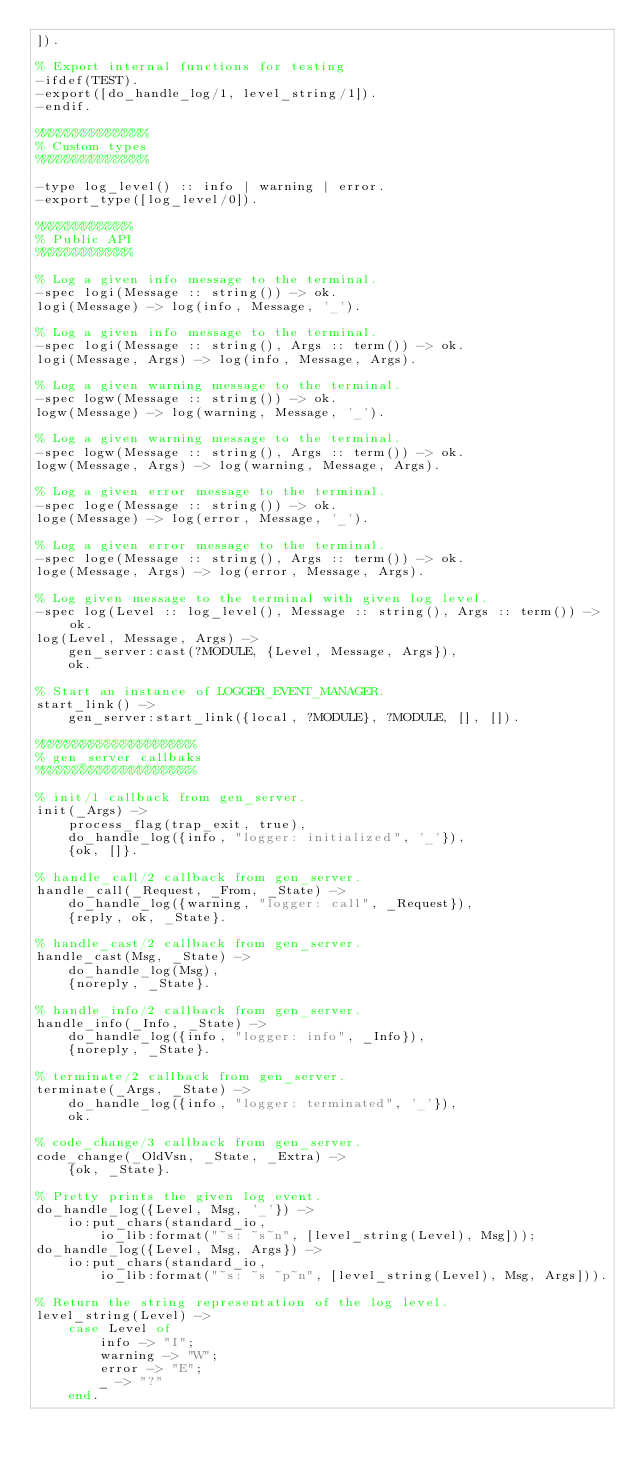Convert code to text. <code><loc_0><loc_0><loc_500><loc_500><_Erlang_>]).

% Export internal functions for testing
-ifdef(TEST).
-export([do_handle_log/1, level_string/1]).
-endif.

%%%%%%%%%%%%%%
% Custom types
%%%%%%%%%%%%%%

-type log_level() :: info | warning | error.
-export_type([log_level/0]).

%%%%%%%%%%%%
% Public API
%%%%%%%%%%%%

% Log a given info message to the terminal.
-spec logi(Message :: string()) -> ok.
logi(Message) -> log(info, Message, '_').

% Log a given info message to the terminal.
-spec logi(Message :: string(), Args :: term()) -> ok.
logi(Message, Args) -> log(info, Message, Args).

% Log a given warning message to the terminal.
-spec logw(Message :: string()) -> ok.
logw(Message) -> log(warning, Message, '_').

% Log a given warning message to the terminal.
-spec logw(Message :: string(), Args :: term()) -> ok.
logw(Message, Args) -> log(warning, Message, Args).

% Log a given error message to the terminal.
-spec loge(Message :: string()) -> ok.
loge(Message) -> log(error, Message, '_').

% Log a given error message to the terminal.
-spec loge(Message :: string(), Args :: term()) -> ok.
loge(Message, Args) -> log(error, Message, Args).

% Log given message to the terminal with given log level.
-spec log(Level :: log_level(), Message :: string(), Args :: term()) -> ok.
log(Level, Message, Args) ->
    gen_server:cast(?MODULE, {Level, Message, Args}),
    ok.

% Start an instance of LOGGER_EVENT_MANAGER.
start_link() ->
    gen_server:start_link({local, ?MODULE}, ?MODULE, [], []).

%%%%%%%%%%%%%%%%%%%%
% gen_server callbaks
%%%%%%%%%%%%%%%%%%%%

% init/1 callback from gen_server.
init(_Args) -> 
    process_flag(trap_exit, true),
    do_handle_log({info, "logger: initialized", '_'}),
    {ok, []}.

% handle_call/2 callback from gen_server.
handle_call(_Request, _From, _State) -> 
    do_handle_log({warning, "logger: call", _Request}),
    {reply, ok, _State}.

% handle_cast/2 callback from gen_server.
handle_cast(Msg, _State) -> 
    do_handle_log(Msg),
    {noreply, _State}.

% handle_info/2 callback from gen_server.
handle_info(_Info, _State) -> 
    do_handle_log({info, "logger: info", _Info}),
    {noreply, _State}.

% terminate/2 callback from gen_server.
terminate(_Args, _State) -> 
    do_handle_log({info, "logger: terminated", '_'}),
    ok.

% code_change/3 callback from gen_server.
code_change(_OldVsn, _State, _Extra) -> 
    {ok, _State}.

% Pretty prints the given log event.
do_handle_log({Level, Msg, '_'}) ->
    io:put_chars(standard_io, 
        io_lib:format("~s: ~s~n", [level_string(Level), Msg]));
do_handle_log({Level, Msg, Args}) ->
    io:put_chars(standard_io, 
        io_lib:format("~s: ~s ~p~n", [level_string(Level), Msg, Args])).

% Return the string representation of the log level.
level_string(Level) ->
    case Level of
        info -> "I";
        warning -> "W";
        error -> "E";
        _ -> "?"
    end.
</code> 